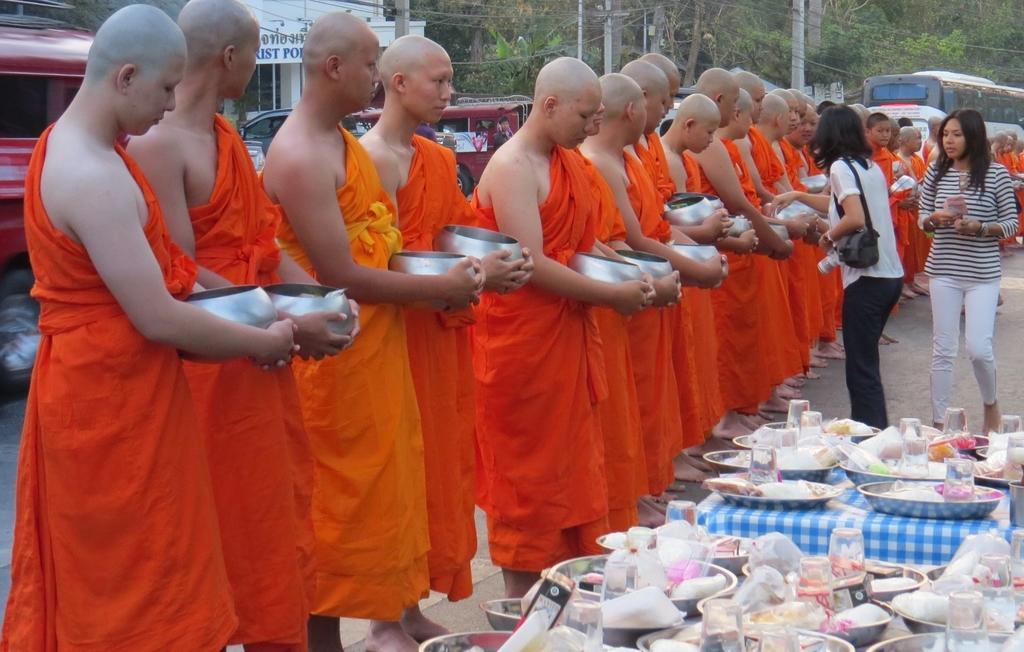Could you give a brief overview of what you see in this image? In this image in front there are people standing on the road by holding the bowls. In front of them there are tables and on top of the tables there are few objects. In the background there are vehicles on the road. There are trees, current poles and buildings. 